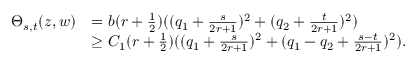Convert formula to latex. <formula><loc_0><loc_0><loc_500><loc_500>\begin{array} { r l } { \Theta _ { s , t } ( z , w ) } & { = b ( r + \frac { 1 } { 2 } ) ( ( q _ { 1 } + \frac { s } { 2 r + 1 } ) ^ { 2 } + ( q _ { 2 } + \frac { t } { 2 r + 1 } ) ^ { 2 } ) } \\ & { \geq C _ { 1 } ( r + \frac { 1 } { 2 } ) ( ( q _ { 1 } + \frac { s } { 2 r + 1 } ) ^ { 2 } + ( q _ { 1 } - q _ { 2 } + \frac { s - t } { 2 r + 1 } ) ^ { 2 } ) . } \end{array}</formula> 